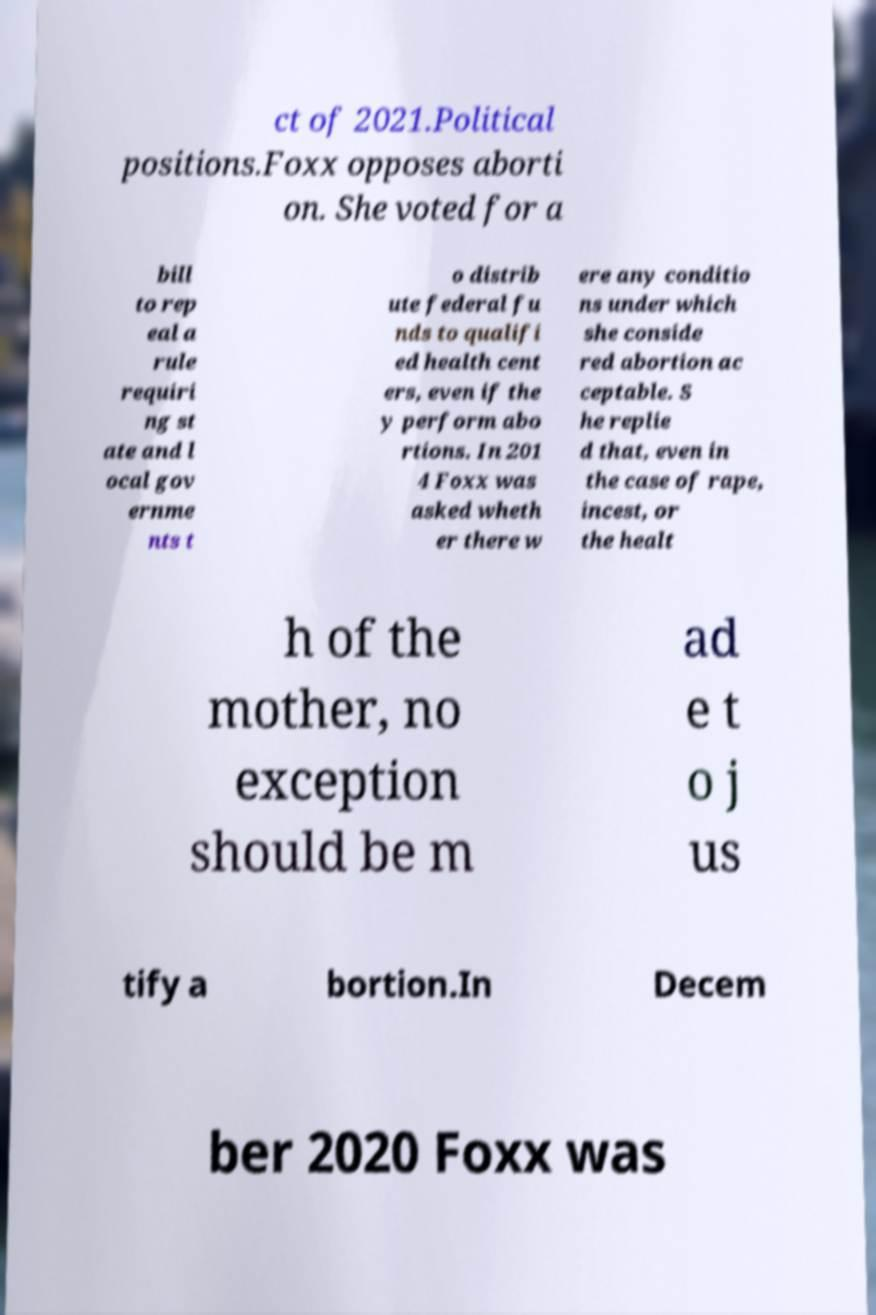I need the written content from this picture converted into text. Can you do that? ct of 2021.Political positions.Foxx opposes aborti on. She voted for a bill to rep eal a rule requiri ng st ate and l ocal gov ernme nts t o distrib ute federal fu nds to qualifi ed health cent ers, even if the y perform abo rtions. In 201 4 Foxx was asked wheth er there w ere any conditio ns under which she conside red abortion ac ceptable. S he replie d that, even in the case of rape, incest, or the healt h of the mother, no exception should be m ad e t o j us tify a bortion.In Decem ber 2020 Foxx was 